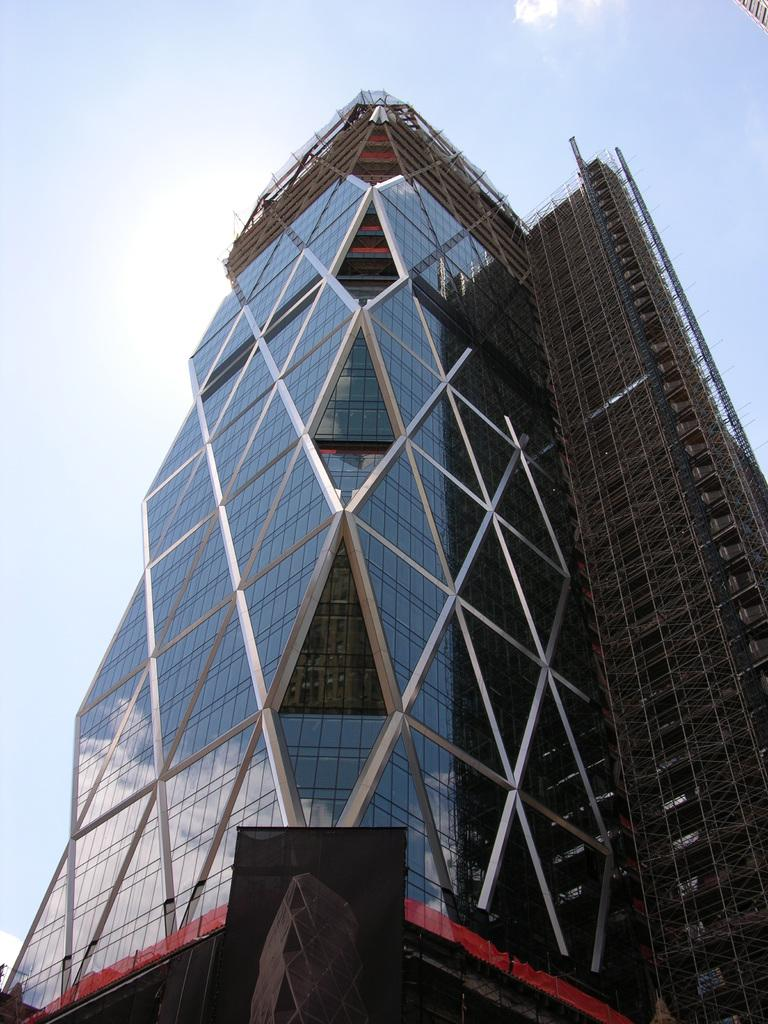What type of structure is present in the image? There is a building in the image. What material can be seen in the image? Metal rods are present in the image. What can be seen in the background of the image? The sky is visible in the background of the image. How many clams can be seen crawling on the metal rods in the image? There are no clams present in the image, and they cannot crawl on metal rods. 